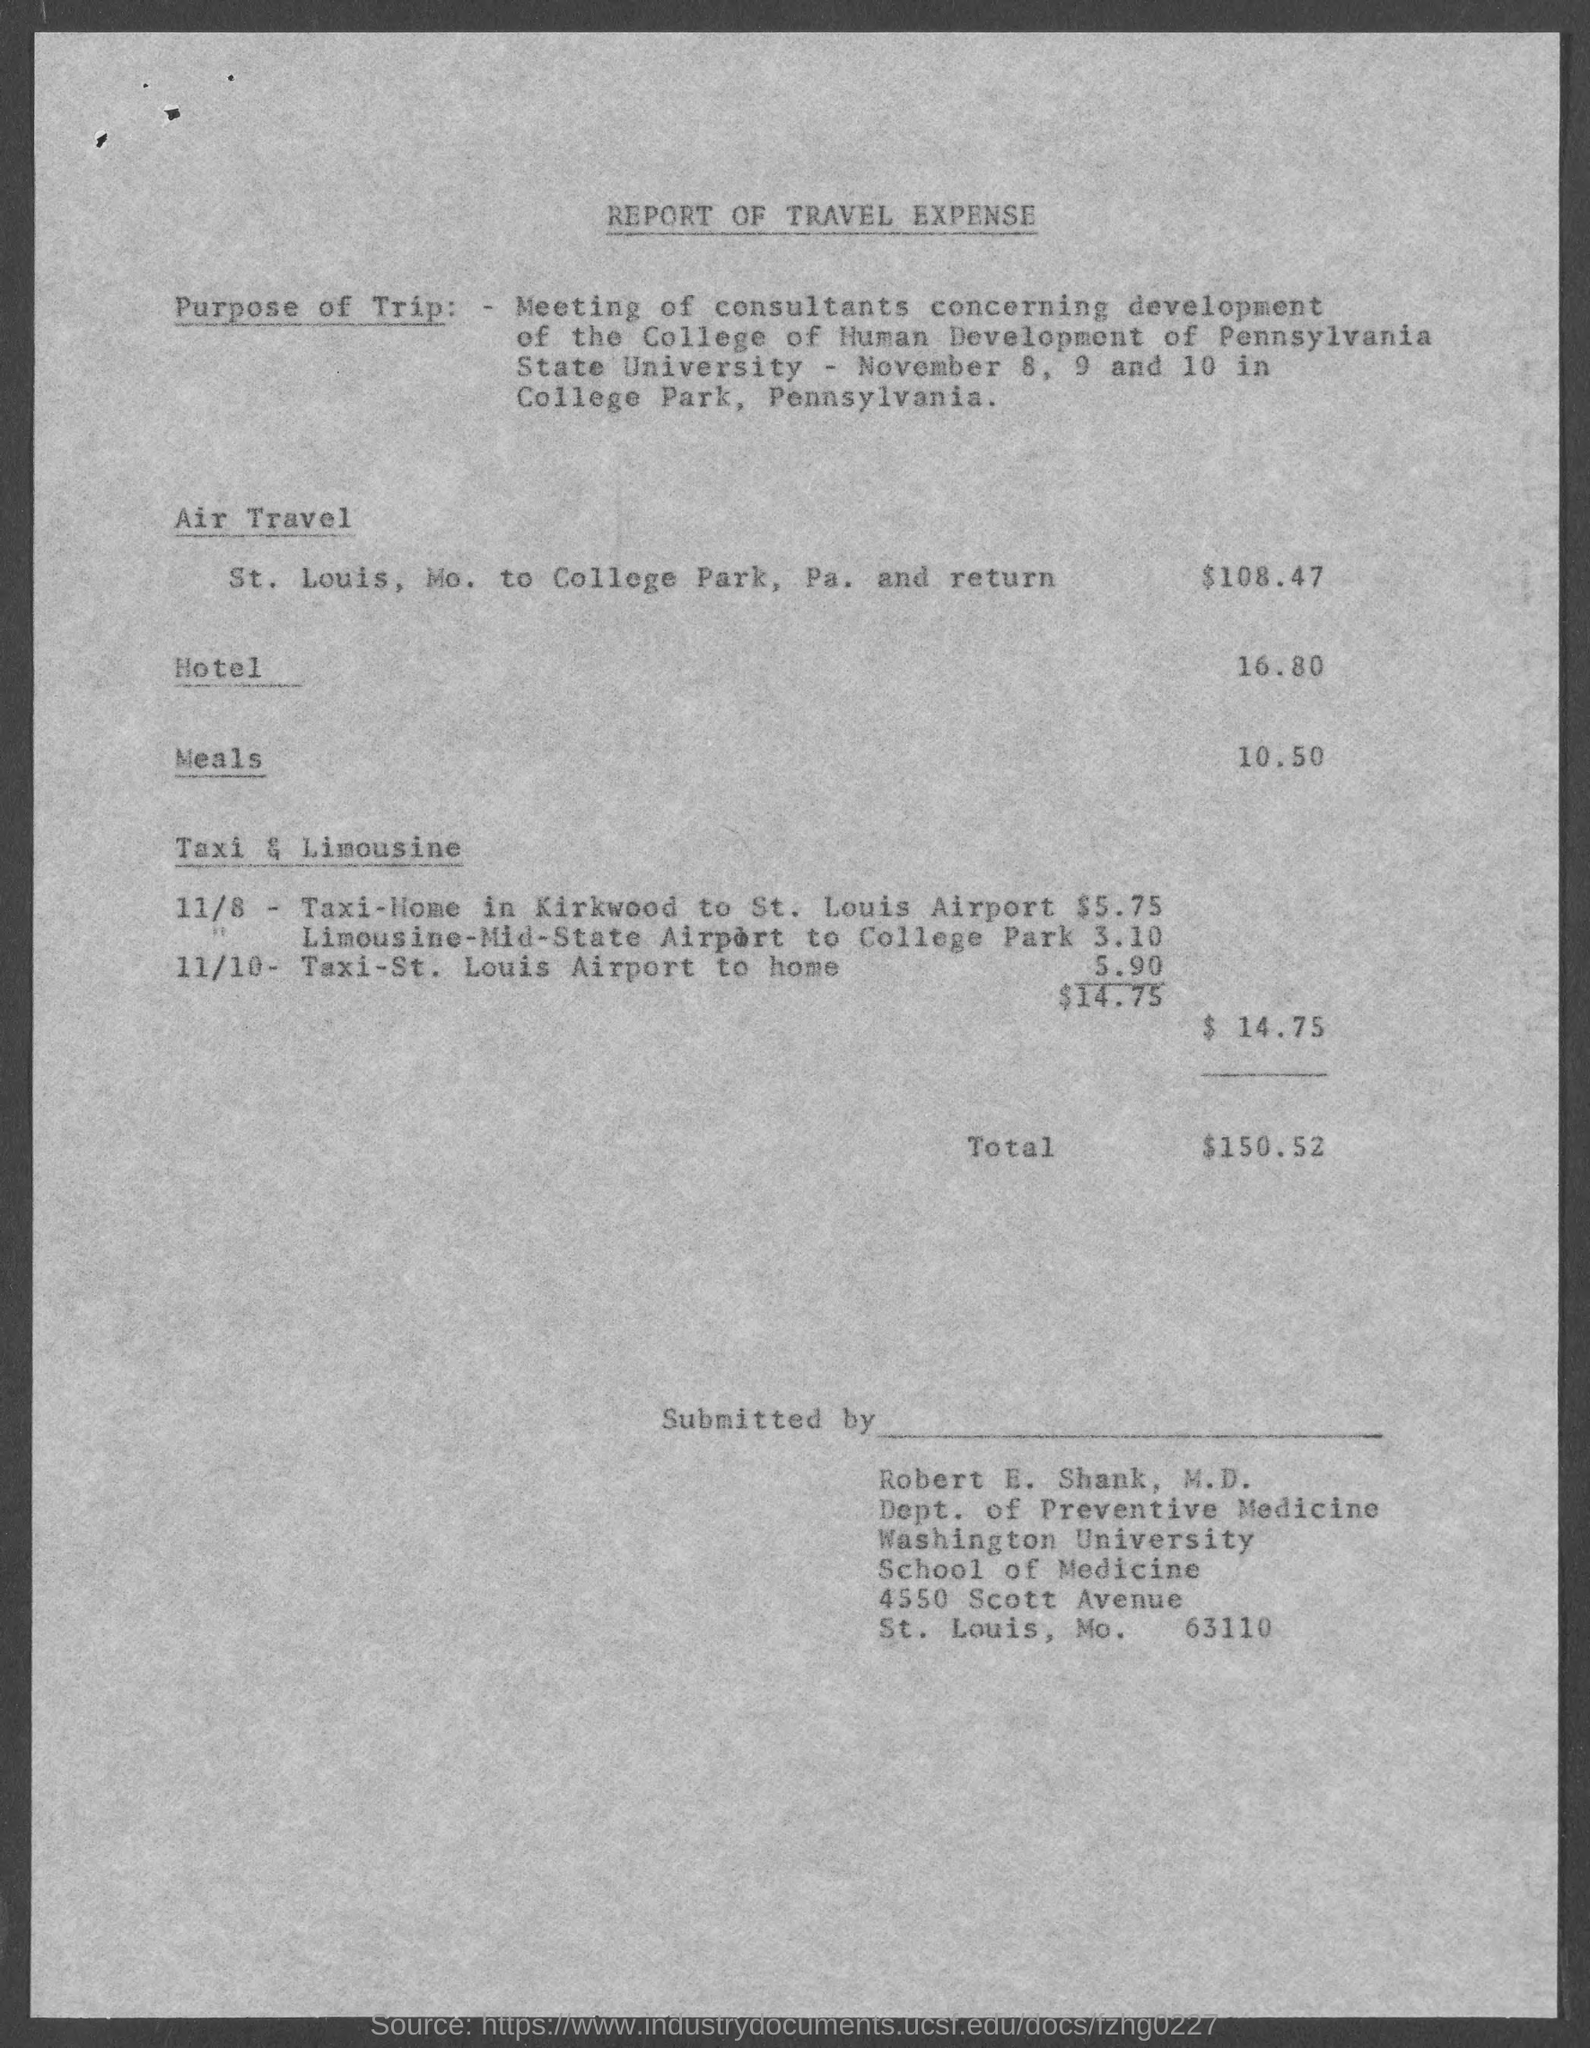Mention a couple of crucial points in this snapshot. This is a declaration that the attached document is a report of travel expenses. The travel expense report has been submitted by Robert E. Shank. The total travel expense mentioned in the document is 150.52. The meeting of consultants was held on November 8, 9, and 10 in College Park, Pennsylvania. The air travel expense mentioned in the document is $108.47. 